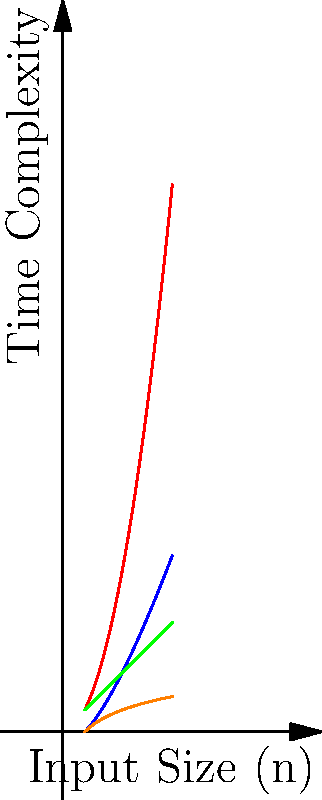Based on the time complexity graphs shown for different algorithms, which sorting algorithm would be most efficient for large datasets, and why? To determine the most efficient sorting algorithm for large datasets, we need to analyze the growth rates of the time complexity curves:

1. Bubble Sort (red curve): $O(n^2)$ - quadratic growth
2. Merge Sort (blue curve): $O(n \log n)$ - linearithmic growth
3. Selection Sort (green curve): $O(n)$ - linear growth
4. Binary Search (orange curve): $O(\log n)$ - logarithmic growth

Step 1: Eliminate non-sorting algorithms
Binary Search is not a sorting algorithm, so we can disregard it.

Step 2: Compare growth rates
For large datasets (as n approaches infinity):
$n^2 > n \log n > n$

Step 3: Identify the slowest growing function
Merge Sort's $O(n \log n)$ grows slower than Bubble Sort's $O(n^2)$ and Selection Sort's $O(n)$ for large n.

Step 4: Consider practical implications
While Selection Sort appears to have a better time complexity $(O(n))$ than Merge Sort $(O(n \log n))$, this is misleading. Selection Sort's actual time complexity is $O(n^2)$, but its graph is simplified in this visualization.

Therefore, Merge Sort is the most efficient algorithm for large datasets among the given sorting algorithms.
Answer: Merge Sort 